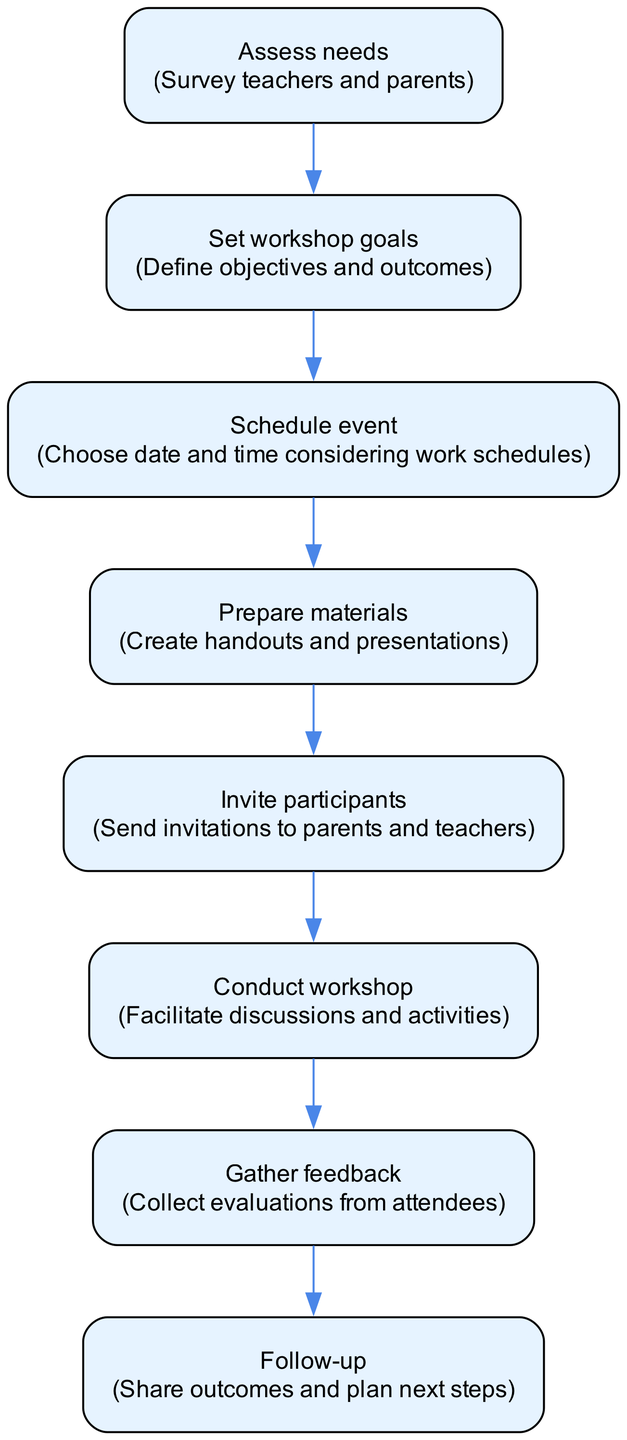What is the first step in the workshop organization process? The first step, as indicated in the diagram, is to "Assess needs." This means the initial action involves surveying teachers and parents to understand their perspectives and requirements.
Answer: Assess needs How many total steps are there in the diagram? By counting the nodes in the flow chart, there are eight distinct steps involved in organizing the workshop. Each step is represented by its own node in the flow.
Answer: Eight What should be done after conducting the workshop? The next step after conducting the workshop is to "Gather feedback," which involves collecting evaluations from attendees to assess their experiences and insights.
Answer: Gather feedback Which step follows after setting workshop goals? After setting workshop goals, the subsequent step is "Schedule event." This action involves choosing a date and time that accommodates the work schedules of parents and teachers.
Answer: Schedule event What is the final action represented in the diagram? The final action in the diagram is to "Follow-up," which entails sharing the outcomes of the workshop and planning the next steps to maintain the collaboration between parents and teachers.
Answer: Follow-up Which two steps are directly connected by a single edge? The steps "Prepare materials" and "Invite participants" are directly connected, indicating the sequence wherein materials must be prepared before invitations can be sent out to participants.
Answer: Prepare materials and Invite participants What is the main purpose of the "Assess needs" step? The main purpose of the "Assess needs" step is to gather insights by surveying teachers and parents to determine their needs and preferences, which will guide the subsequent planning stages.
Answer: Survey teachers and parents Which steps involve interactions with parents? The steps that involve interactions with parents are "Assess needs," "Invite participants," and "Gather feedback," as they directly solicit input and participation from parents in the workshop.
Answer: Assess needs, Invite participants, Gather feedback 